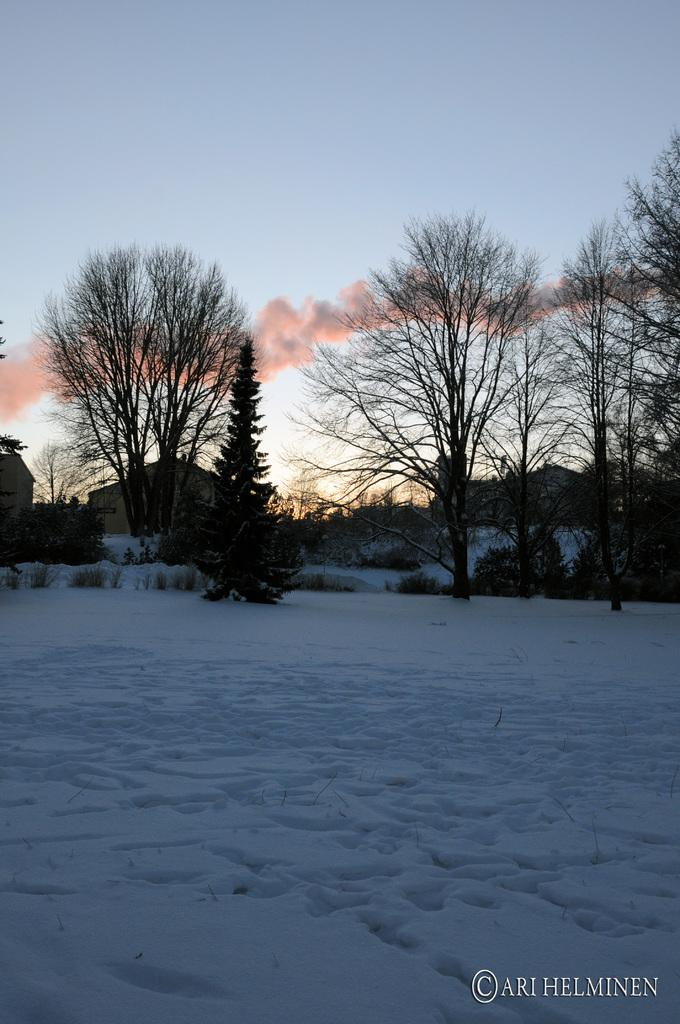What type of vegetation can be seen in the image? There are trees in the image. What type of structures are present in the image? There are sheds in the image. What is covering the ground in the image? There is snow at the bottom of the image. What is visible at the top of the image? The sky is visible at the top of the image. Where is the chessboard located in the image? There is no chessboard present in the image. What color is the spot on the tree in the image? There is no spot on the tree in the image. 